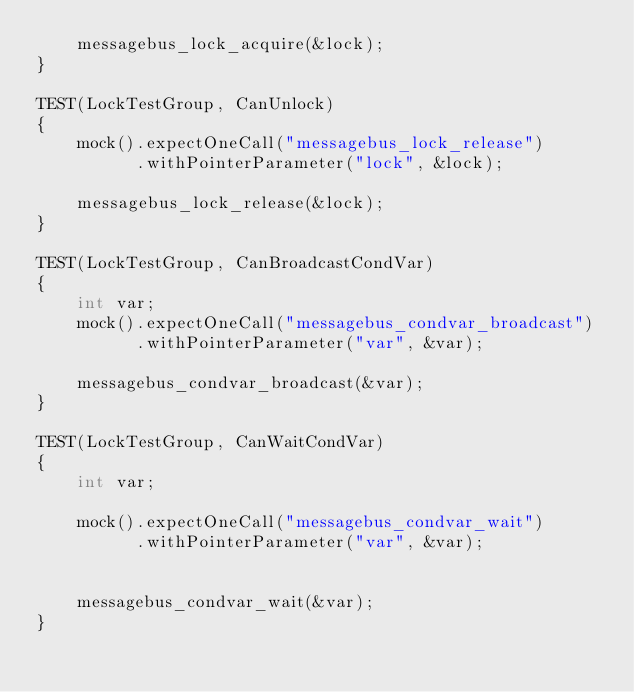Convert code to text. <code><loc_0><loc_0><loc_500><loc_500><_C++_>    messagebus_lock_acquire(&lock);
}

TEST(LockTestGroup, CanUnlock)
{
    mock().expectOneCall("messagebus_lock_release")
          .withPointerParameter("lock", &lock);

    messagebus_lock_release(&lock);
}

TEST(LockTestGroup, CanBroadcastCondVar)
{
    int var;
    mock().expectOneCall("messagebus_condvar_broadcast")
          .withPointerParameter("var", &var);

    messagebus_condvar_broadcast(&var);
}

TEST(LockTestGroup, CanWaitCondVar)
{
    int var;

    mock().expectOneCall("messagebus_condvar_wait")
          .withPointerParameter("var", &var);


    messagebus_condvar_wait(&var);
}
</code> 